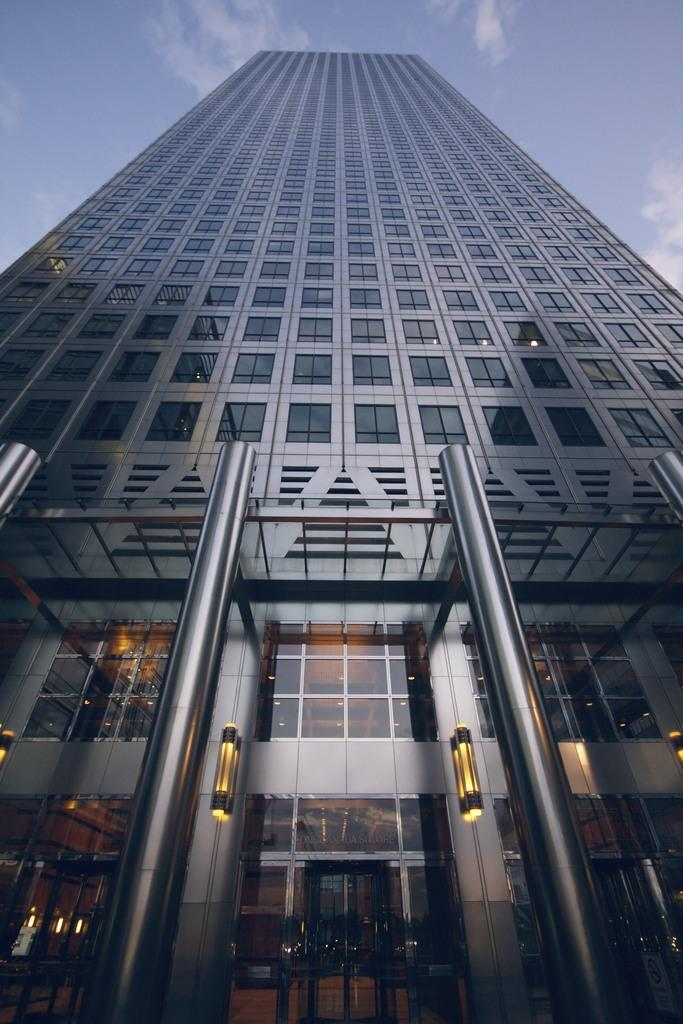What type of structure is present in the image? There is a building in the image. What feature can be observed on the building? The building has glass windows and doors. What can be seen illuminated in the image? There are lights visible in the image. What is visible at the top of the image? The sky is visible at the top of the image. What direction is the building facing in the image? The provided facts do not indicate the direction the building is facing. --- 